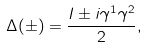Convert formula to latex. <formula><loc_0><loc_0><loc_500><loc_500>\Delta ( \pm ) = \frac { I \pm i \gamma ^ { 1 } \gamma ^ { 2 } } { 2 } ,</formula> 